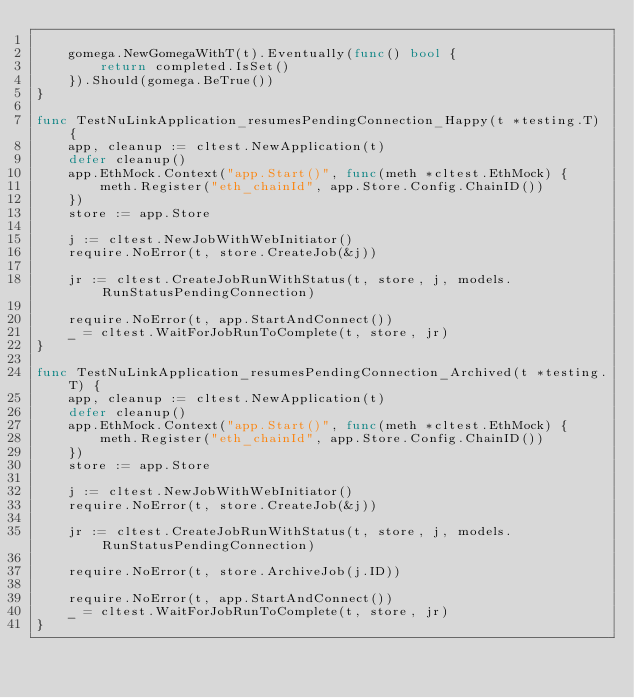Convert code to text. <code><loc_0><loc_0><loc_500><loc_500><_Go_>
	gomega.NewGomegaWithT(t).Eventually(func() bool {
		return completed.IsSet()
	}).Should(gomega.BeTrue())
}

func TestNuLinkApplication_resumesPendingConnection_Happy(t *testing.T) {
	app, cleanup := cltest.NewApplication(t)
	defer cleanup()
	app.EthMock.Context("app.Start()", func(meth *cltest.EthMock) {
		meth.Register("eth_chainId", app.Store.Config.ChainID())
	})
	store := app.Store

	j := cltest.NewJobWithWebInitiator()
	require.NoError(t, store.CreateJob(&j))

	jr := cltest.CreateJobRunWithStatus(t, store, j, models.RunStatusPendingConnection)

	require.NoError(t, app.StartAndConnect())
	_ = cltest.WaitForJobRunToComplete(t, store, jr)
}

func TestNuLinkApplication_resumesPendingConnection_Archived(t *testing.T) {
	app, cleanup := cltest.NewApplication(t)
	defer cleanup()
	app.EthMock.Context("app.Start()", func(meth *cltest.EthMock) {
		meth.Register("eth_chainId", app.Store.Config.ChainID())
	})
	store := app.Store

	j := cltest.NewJobWithWebInitiator()
	require.NoError(t, store.CreateJob(&j))

	jr := cltest.CreateJobRunWithStatus(t, store, j, models.RunStatusPendingConnection)

	require.NoError(t, store.ArchiveJob(j.ID))

	require.NoError(t, app.StartAndConnect())
	_ = cltest.WaitForJobRunToComplete(t, store, jr)
}
</code> 